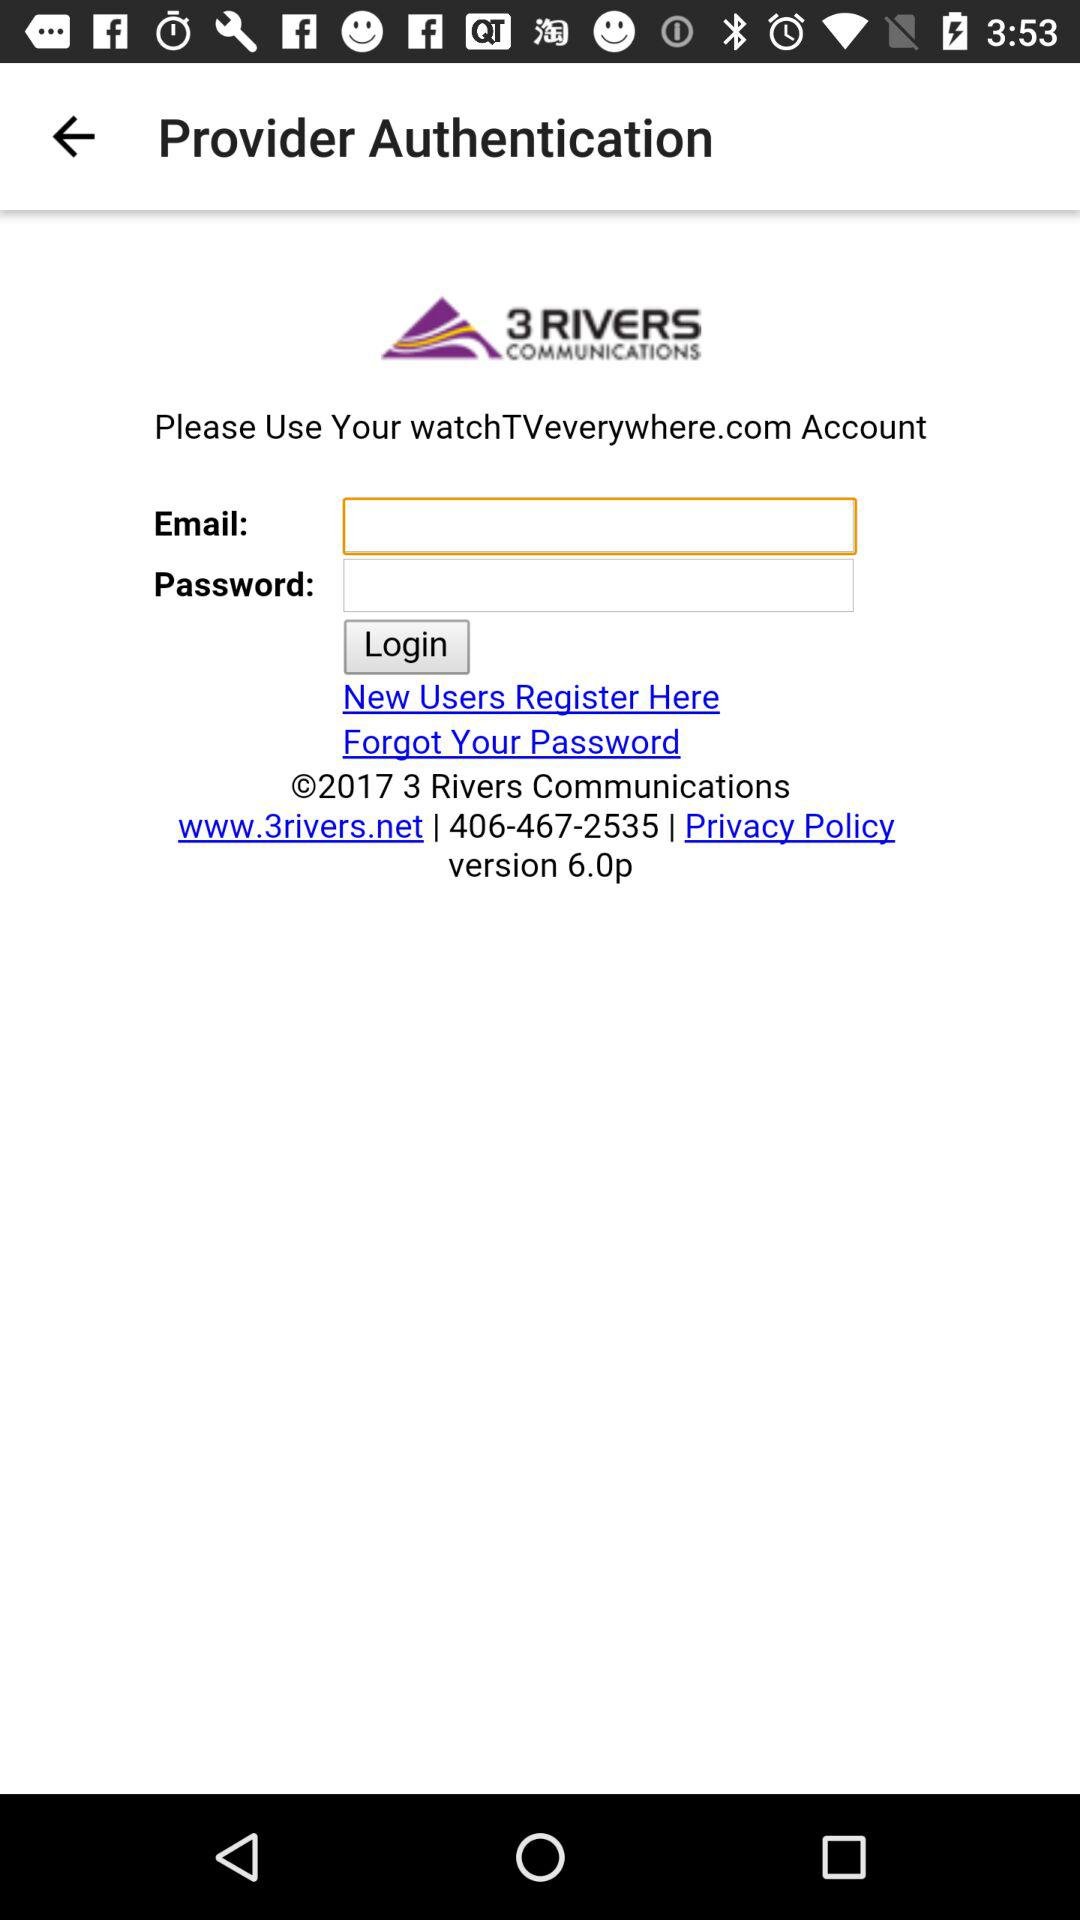What is the website? The websites are watchTVeverywhere.com and www.3rivers.net. 